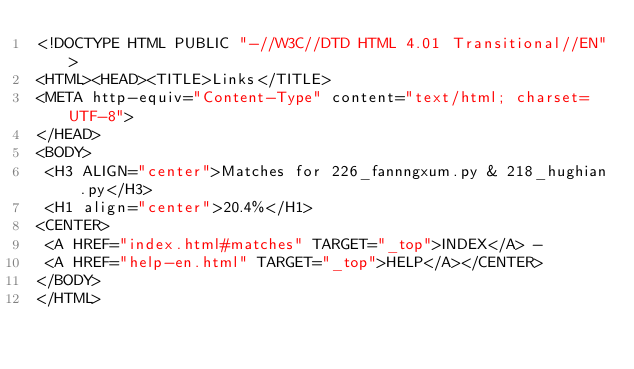<code> <loc_0><loc_0><loc_500><loc_500><_HTML_><!DOCTYPE HTML PUBLIC "-//W3C//DTD HTML 4.01 Transitional//EN">
<HTML><HEAD><TITLE>Links</TITLE>
<META http-equiv="Content-Type" content="text/html; charset=UTF-8">
</HEAD>
<BODY>
 <H3 ALIGN="center">Matches for 226_fannngxum.py & 218_hughian.py</H3>
 <H1 align="center">20.4%</H1>
<CENTER>
 <A HREF="index.html#matches" TARGET="_top">INDEX</A> - 
 <A HREF="help-en.html" TARGET="_top">HELP</A></CENTER>
</BODY>
</HTML>
</code> 